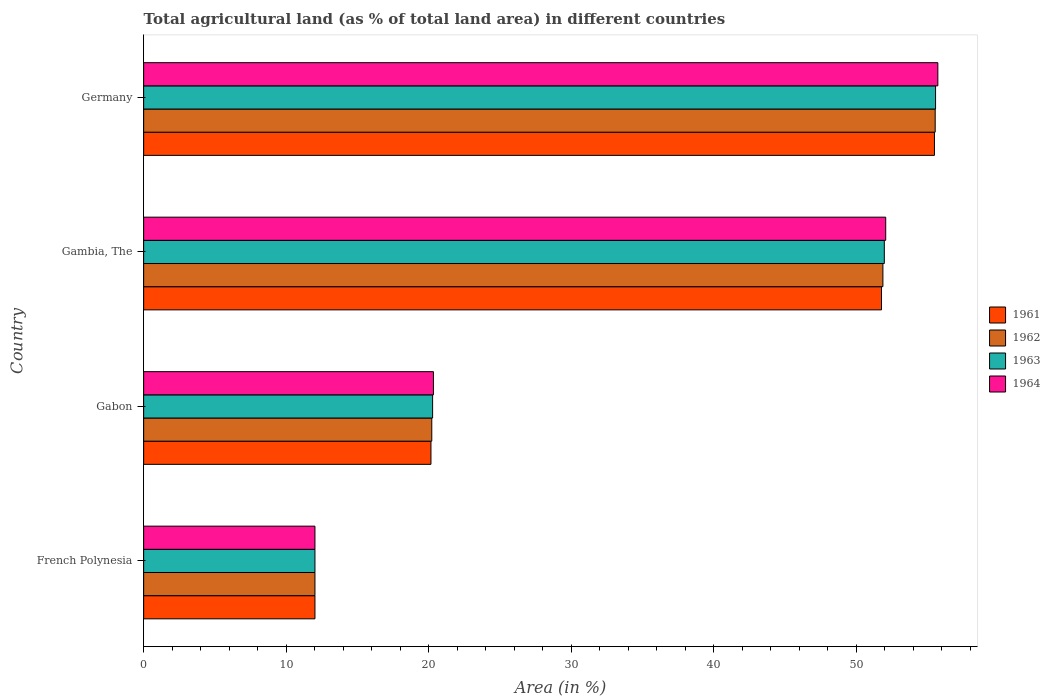How many different coloured bars are there?
Provide a short and direct response. 4. How many groups of bars are there?
Offer a terse response. 4. How many bars are there on the 1st tick from the top?
Provide a short and direct response. 4. How many bars are there on the 3rd tick from the bottom?
Provide a succinct answer. 4. What is the label of the 4th group of bars from the top?
Offer a terse response. French Polynesia. What is the percentage of agricultural land in 1964 in Germany?
Ensure brevity in your answer.  55.73. Across all countries, what is the maximum percentage of agricultural land in 1961?
Offer a very short reply. 55.5. Across all countries, what is the minimum percentage of agricultural land in 1962?
Your answer should be compact. 12.02. In which country was the percentage of agricultural land in 1963 minimum?
Offer a terse response. French Polynesia. What is the total percentage of agricultural land in 1962 in the graph?
Ensure brevity in your answer.  139.67. What is the difference between the percentage of agricultural land in 1963 in Gambia, The and that in Germany?
Make the answer very short. -3.6. What is the difference between the percentage of agricultural land in 1963 in Gabon and the percentage of agricultural land in 1964 in French Polynesia?
Give a very brief answer. 8.26. What is the average percentage of agricultural land in 1962 per country?
Your response must be concise. 34.92. What is the ratio of the percentage of agricultural land in 1963 in French Polynesia to that in Gabon?
Your response must be concise. 0.59. Is the percentage of agricultural land in 1963 in Gabon less than that in Germany?
Ensure brevity in your answer.  Yes. What is the difference between the highest and the second highest percentage of agricultural land in 1961?
Your answer should be compact. 3.72. What is the difference between the highest and the lowest percentage of agricultural land in 1962?
Your answer should be compact. 43.52. In how many countries, is the percentage of agricultural land in 1963 greater than the average percentage of agricultural land in 1963 taken over all countries?
Offer a very short reply. 2. Is the sum of the percentage of agricultural land in 1961 in Gabon and Germany greater than the maximum percentage of agricultural land in 1964 across all countries?
Your answer should be very brief. Yes. Is it the case that in every country, the sum of the percentage of agricultural land in 1963 and percentage of agricultural land in 1964 is greater than the sum of percentage of agricultural land in 1962 and percentage of agricultural land in 1961?
Give a very brief answer. No. What does the 2nd bar from the top in Gambia, The represents?
Provide a succinct answer. 1963. What does the 4th bar from the bottom in French Polynesia represents?
Keep it short and to the point. 1964. Are all the bars in the graph horizontal?
Ensure brevity in your answer.  Yes. How many countries are there in the graph?
Keep it short and to the point. 4. How many legend labels are there?
Ensure brevity in your answer.  4. How are the legend labels stacked?
Offer a terse response. Vertical. What is the title of the graph?
Offer a very short reply. Total agricultural land (as % of total land area) in different countries. Does "1997" appear as one of the legend labels in the graph?
Give a very brief answer. No. What is the label or title of the X-axis?
Your answer should be very brief. Area (in %). What is the Area (in %) of 1961 in French Polynesia?
Offer a terse response. 12.02. What is the Area (in %) of 1962 in French Polynesia?
Give a very brief answer. 12.02. What is the Area (in %) of 1963 in French Polynesia?
Give a very brief answer. 12.02. What is the Area (in %) of 1964 in French Polynesia?
Provide a short and direct response. 12.02. What is the Area (in %) in 1961 in Gabon?
Ensure brevity in your answer.  20.16. What is the Area (in %) in 1962 in Gabon?
Offer a very short reply. 20.22. What is the Area (in %) in 1963 in Gabon?
Your answer should be very brief. 20.28. What is the Area (in %) of 1964 in Gabon?
Your answer should be very brief. 20.34. What is the Area (in %) of 1961 in Gambia, The?
Your answer should be very brief. 51.78. What is the Area (in %) in 1962 in Gambia, The?
Your answer should be compact. 51.88. What is the Area (in %) of 1963 in Gambia, The?
Your answer should be compact. 51.98. What is the Area (in %) in 1964 in Gambia, The?
Your answer should be very brief. 52.08. What is the Area (in %) of 1961 in Germany?
Your answer should be very brief. 55.5. What is the Area (in %) of 1962 in Germany?
Ensure brevity in your answer.  55.55. What is the Area (in %) of 1963 in Germany?
Keep it short and to the point. 55.57. What is the Area (in %) in 1964 in Germany?
Your answer should be very brief. 55.73. Across all countries, what is the maximum Area (in %) of 1961?
Provide a succinct answer. 55.5. Across all countries, what is the maximum Area (in %) of 1962?
Provide a short and direct response. 55.55. Across all countries, what is the maximum Area (in %) in 1963?
Provide a succinct answer. 55.57. Across all countries, what is the maximum Area (in %) in 1964?
Provide a short and direct response. 55.73. Across all countries, what is the minimum Area (in %) in 1961?
Keep it short and to the point. 12.02. Across all countries, what is the minimum Area (in %) of 1962?
Give a very brief answer. 12.02. Across all countries, what is the minimum Area (in %) of 1963?
Your response must be concise. 12.02. Across all countries, what is the minimum Area (in %) of 1964?
Provide a short and direct response. 12.02. What is the total Area (in %) in 1961 in the graph?
Your answer should be compact. 139.46. What is the total Area (in %) in 1962 in the graph?
Provide a short and direct response. 139.67. What is the total Area (in %) in 1963 in the graph?
Make the answer very short. 139.85. What is the total Area (in %) of 1964 in the graph?
Give a very brief answer. 140.17. What is the difference between the Area (in %) in 1961 in French Polynesia and that in Gabon?
Offer a terse response. -8.14. What is the difference between the Area (in %) of 1962 in French Polynesia and that in Gabon?
Give a very brief answer. -8.2. What is the difference between the Area (in %) in 1963 in French Polynesia and that in Gabon?
Make the answer very short. -8.26. What is the difference between the Area (in %) of 1964 in French Polynesia and that in Gabon?
Ensure brevity in your answer.  -8.31. What is the difference between the Area (in %) of 1961 in French Polynesia and that in Gambia, The?
Offer a terse response. -39.76. What is the difference between the Area (in %) of 1962 in French Polynesia and that in Gambia, The?
Your answer should be compact. -39.86. What is the difference between the Area (in %) of 1963 in French Polynesia and that in Gambia, The?
Provide a short and direct response. -39.95. What is the difference between the Area (in %) in 1964 in French Polynesia and that in Gambia, The?
Your answer should be compact. -40.05. What is the difference between the Area (in %) of 1961 in French Polynesia and that in Germany?
Ensure brevity in your answer.  -43.47. What is the difference between the Area (in %) in 1962 in French Polynesia and that in Germany?
Your answer should be very brief. -43.52. What is the difference between the Area (in %) in 1963 in French Polynesia and that in Germany?
Offer a very short reply. -43.55. What is the difference between the Area (in %) of 1964 in French Polynesia and that in Germany?
Give a very brief answer. -43.71. What is the difference between the Area (in %) in 1961 in Gabon and that in Gambia, The?
Keep it short and to the point. -31.62. What is the difference between the Area (in %) of 1962 in Gabon and that in Gambia, The?
Your answer should be very brief. -31.66. What is the difference between the Area (in %) in 1963 in Gabon and that in Gambia, The?
Make the answer very short. -31.7. What is the difference between the Area (in %) of 1964 in Gabon and that in Gambia, The?
Give a very brief answer. -31.74. What is the difference between the Area (in %) of 1961 in Gabon and that in Germany?
Offer a very short reply. -35.33. What is the difference between the Area (in %) of 1962 in Gabon and that in Germany?
Your response must be concise. -35.33. What is the difference between the Area (in %) in 1963 in Gabon and that in Germany?
Keep it short and to the point. -35.29. What is the difference between the Area (in %) of 1964 in Gabon and that in Germany?
Provide a succinct answer. -35.4. What is the difference between the Area (in %) of 1961 in Gambia, The and that in Germany?
Provide a short and direct response. -3.72. What is the difference between the Area (in %) of 1962 in Gambia, The and that in Germany?
Ensure brevity in your answer.  -3.67. What is the difference between the Area (in %) in 1963 in Gambia, The and that in Germany?
Give a very brief answer. -3.6. What is the difference between the Area (in %) of 1964 in Gambia, The and that in Germany?
Your answer should be very brief. -3.66. What is the difference between the Area (in %) in 1961 in French Polynesia and the Area (in %) in 1962 in Gabon?
Make the answer very short. -8.2. What is the difference between the Area (in %) in 1961 in French Polynesia and the Area (in %) in 1963 in Gabon?
Offer a terse response. -8.26. What is the difference between the Area (in %) of 1961 in French Polynesia and the Area (in %) of 1964 in Gabon?
Ensure brevity in your answer.  -8.31. What is the difference between the Area (in %) in 1962 in French Polynesia and the Area (in %) in 1963 in Gabon?
Ensure brevity in your answer.  -8.26. What is the difference between the Area (in %) in 1962 in French Polynesia and the Area (in %) in 1964 in Gabon?
Give a very brief answer. -8.31. What is the difference between the Area (in %) in 1963 in French Polynesia and the Area (in %) in 1964 in Gabon?
Give a very brief answer. -8.31. What is the difference between the Area (in %) of 1961 in French Polynesia and the Area (in %) of 1962 in Gambia, The?
Provide a short and direct response. -39.86. What is the difference between the Area (in %) in 1961 in French Polynesia and the Area (in %) in 1963 in Gambia, The?
Give a very brief answer. -39.95. What is the difference between the Area (in %) of 1961 in French Polynesia and the Area (in %) of 1964 in Gambia, The?
Make the answer very short. -40.05. What is the difference between the Area (in %) of 1962 in French Polynesia and the Area (in %) of 1963 in Gambia, The?
Offer a very short reply. -39.95. What is the difference between the Area (in %) in 1962 in French Polynesia and the Area (in %) in 1964 in Gambia, The?
Your response must be concise. -40.05. What is the difference between the Area (in %) of 1963 in French Polynesia and the Area (in %) of 1964 in Gambia, The?
Keep it short and to the point. -40.05. What is the difference between the Area (in %) of 1961 in French Polynesia and the Area (in %) of 1962 in Germany?
Provide a short and direct response. -43.52. What is the difference between the Area (in %) in 1961 in French Polynesia and the Area (in %) in 1963 in Germany?
Your response must be concise. -43.55. What is the difference between the Area (in %) in 1961 in French Polynesia and the Area (in %) in 1964 in Germany?
Your answer should be very brief. -43.71. What is the difference between the Area (in %) in 1962 in French Polynesia and the Area (in %) in 1963 in Germany?
Your answer should be very brief. -43.55. What is the difference between the Area (in %) in 1962 in French Polynesia and the Area (in %) in 1964 in Germany?
Your answer should be compact. -43.71. What is the difference between the Area (in %) of 1963 in French Polynesia and the Area (in %) of 1964 in Germany?
Provide a succinct answer. -43.71. What is the difference between the Area (in %) of 1961 in Gabon and the Area (in %) of 1962 in Gambia, The?
Offer a terse response. -31.72. What is the difference between the Area (in %) in 1961 in Gabon and the Area (in %) in 1963 in Gambia, The?
Offer a very short reply. -31.81. What is the difference between the Area (in %) of 1961 in Gabon and the Area (in %) of 1964 in Gambia, The?
Provide a short and direct response. -31.91. What is the difference between the Area (in %) in 1962 in Gabon and the Area (in %) in 1963 in Gambia, The?
Offer a terse response. -31.76. What is the difference between the Area (in %) of 1962 in Gabon and the Area (in %) of 1964 in Gambia, The?
Ensure brevity in your answer.  -31.86. What is the difference between the Area (in %) of 1963 in Gabon and the Area (in %) of 1964 in Gambia, The?
Keep it short and to the point. -31.8. What is the difference between the Area (in %) of 1961 in Gabon and the Area (in %) of 1962 in Germany?
Provide a succinct answer. -35.39. What is the difference between the Area (in %) of 1961 in Gabon and the Area (in %) of 1963 in Germany?
Make the answer very short. -35.41. What is the difference between the Area (in %) of 1961 in Gabon and the Area (in %) of 1964 in Germany?
Offer a terse response. -35.57. What is the difference between the Area (in %) of 1962 in Gabon and the Area (in %) of 1963 in Germany?
Your answer should be very brief. -35.35. What is the difference between the Area (in %) of 1962 in Gabon and the Area (in %) of 1964 in Germany?
Provide a succinct answer. -35.51. What is the difference between the Area (in %) of 1963 in Gabon and the Area (in %) of 1964 in Germany?
Ensure brevity in your answer.  -35.45. What is the difference between the Area (in %) of 1961 in Gambia, The and the Area (in %) of 1962 in Germany?
Offer a terse response. -3.77. What is the difference between the Area (in %) of 1961 in Gambia, The and the Area (in %) of 1963 in Germany?
Keep it short and to the point. -3.79. What is the difference between the Area (in %) of 1961 in Gambia, The and the Area (in %) of 1964 in Germany?
Keep it short and to the point. -3.95. What is the difference between the Area (in %) in 1962 in Gambia, The and the Area (in %) in 1963 in Germany?
Give a very brief answer. -3.69. What is the difference between the Area (in %) in 1962 in Gambia, The and the Area (in %) in 1964 in Germany?
Your answer should be compact. -3.86. What is the difference between the Area (in %) in 1963 in Gambia, The and the Area (in %) in 1964 in Germany?
Your response must be concise. -3.76. What is the average Area (in %) in 1961 per country?
Your answer should be compact. 34.86. What is the average Area (in %) in 1962 per country?
Give a very brief answer. 34.92. What is the average Area (in %) in 1963 per country?
Provide a succinct answer. 34.96. What is the average Area (in %) of 1964 per country?
Provide a short and direct response. 35.04. What is the difference between the Area (in %) in 1961 and Area (in %) in 1963 in French Polynesia?
Your response must be concise. 0. What is the difference between the Area (in %) of 1961 and Area (in %) of 1964 in French Polynesia?
Ensure brevity in your answer.  0. What is the difference between the Area (in %) of 1962 and Area (in %) of 1964 in French Polynesia?
Your response must be concise. 0. What is the difference between the Area (in %) of 1963 and Area (in %) of 1964 in French Polynesia?
Make the answer very short. 0. What is the difference between the Area (in %) of 1961 and Area (in %) of 1962 in Gabon?
Ensure brevity in your answer.  -0.06. What is the difference between the Area (in %) in 1961 and Area (in %) in 1963 in Gabon?
Make the answer very short. -0.12. What is the difference between the Area (in %) of 1961 and Area (in %) of 1964 in Gabon?
Your answer should be compact. -0.17. What is the difference between the Area (in %) in 1962 and Area (in %) in 1963 in Gabon?
Your answer should be compact. -0.06. What is the difference between the Area (in %) of 1962 and Area (in %) of 1964 in Gabon?
Your answer should be very brief. -0.12. What is the difference between the Area (in %) of 1963 and Area (in %) of 1964 in Gabon?
Make the answer very short. -0.06. What is the difference between the Area (in %) of 1961 and Area (in %) of 1962 in Gambia, The?
Provide a succinct answer. -0.1. What is the difference between the Area (in %) of 1961 and Area (in %) of 1963 in Gambia, The?
Make the answer very short. -0.2. What is the difference between the Area (in %) of 1961 and Area (in %) of 1964 in Gambia, The?
Offer a terse response. -0.3. What is the difference between the Area (in %) in 1962 and Area (in %) in 1963 in Gambia, The?
Your answer should be compact. -0.1. What is the difference between the Area (in %) in 1962 and Area (in %) in 1964 in Gambia, The?
Your response must be concise. -0.2. What is the difference between the Area (in %) in 1963 and Area (in %) in 1964 in Gambia, The?
Offer a very short reply. -0.1. What is the difference between the Area (in %) of 1961 and Area (in %) of 1962 in Germany?
Offer a terse response. -0.05. What is the difference between the Area (in %) of 1961 and Area (in %) of 1963 in Germany?
Your answer should be very brief. -0.08. What is the difference between the Area (in %) in 1961 and Area (in %) in 1964 in Germany?
Ensure brevity in your answer.  -0.24. What is the difference between the Area (in %) in 1962 and Area (in %) in 1963 in Germany?
Provide a succinct answer. -0.03. What is the difference between the Area (in %) of 1962 and Area (in %) of 1964 in Germany?
Your response must be concise. -0.19. What is the difference between the Area (in %) in 1963 and Area (in %) in 1964 in Germany?
Keep it short and to the point. -0.16. What is the ratio of the Area (in %) in 1961 in French Polynesia to that in Gabon?
Give a very brief answer. 0.6. What is the ratio of the Area (in %) in 1962 in French Polynesia to that in Gabon?
Ensure brevity in your answer.  0.59. What is the ratio of the Area (in %) of 1963 in French Polynesia to that in Gabon?
Offer a very short reply. 0.59. What is the ratio of the Area (in %) of 1964 in French Polynesia to that in Gabon?
Offer a very short reply. 0.59. What is the ratio of the Area (in %) in 1961 in French Polynesia to that in Gambia, The?
Offer a terse response. 0.23. What is the ratio of the Area (in %) of 1962 in French Polynesia to that in Gambia, The?
Provide a succinct answer. 0.23. What is the ratio of the Area (in %) of 1963 in French Polynesia to that in Gambia, The?
Give a very brief answer. 0.23. What is the ratio of the Area (in %) of 1964 in French Polynesia to that in Gambia, The?
Ensure brevity in your answer.  0.23. What is the ratio of the Area (in %) of 1961 in French Polynesia to that in Germany?
Make the answer very short. 0.22. What is the ratio of the Area (in %) in 1962 in French Polynesia to that in Germany?
Provide a short and direct response. 0.22. What is the ratio of the Area (in %) of 1963 in French Polynesia to that in Germany?
Make the answer very short. 0.22. What is the ratio of the Area (in %) of 1964 in French Polynesia to that in Germany?
Provide a short and direct response. 0.22. What is the ratio of the Area (in %) in 1961 in Gabon to that in Gambia, The?
Provide a short and direct response. 0.39. What is the ratio of the Area (in %) of 1962 in Gabon to that in Gambia, The?
Provide a succinct answer. 0.39. What is the ratio of the Area (in %) in 1963 in Gabon to that in Gambia, The?
Your response must be concise. 0.39. What is the ratio of the Area (in %) in 1964 in Gabon to that in Gambia, The?
Give a very brief answer. 0.39. What is the ratio of the Area (in %) in 1961 in Gabon to that in Germany?
Provide a succinct answer. 0.36. What is the ratio of the Area (in %) of 1962 in Gabon to that in Germany?
Your answer should be compact. 0.36. What is the ratio of the Area (in %) in 1963 in Gabon to that in Germany?
Make the answer very short. 0.36. What is the ratio of the Area (in %) of 1964 in Gabon to that in Germany?
Offer a terse response. 0.36. What is the ratio of the Area (in %) of 1961 in Gambia, The to that in Germany?
Ensure brevity in your answer.  0.93. What is the ratio of the Area (in %) of 1962 in Gambia, The to that in Germany?
Keep it short and to the point. 0.93. What is the ratio of the Area (in %) of 1963 in Gambia, The to that in Germany?
Give a very brief answer. 0.94. What is the ratio of the Area (in %) of 1964 in Gambia, The to that in Germany?
Your answer should be very brief. 0.93. What is the difference between the highest and the second highest Area (in %) in 1961?
Keep it short and to the point. 3.72. What is the difference between the highest and the second highest Area (in %) of 1962?
Your response must be concise. 3.67. What is the difference between the highest and the second highest Area (in %) of 1963?
Your response must be concise. 3.6. What is the difference between the highest and the second highest Area (in %) in 1964?
Your answer should be very brief. 3.66. What is the difference between the highest and the lowest Area (in %) of 1961?
Offer a very short reply. 43.47. What is the difference between the highest and the lowest Area (in %) in 1962?
Ensure brevity in your answer.  43.52. What is the difference between the highest and the lowest Area (in %) in 1963?
Keep it short and to the point. 43.55. What is the difference between the highest and the lowest Area (in %) of 1964?
Keep it short and to the point. 43.71. 